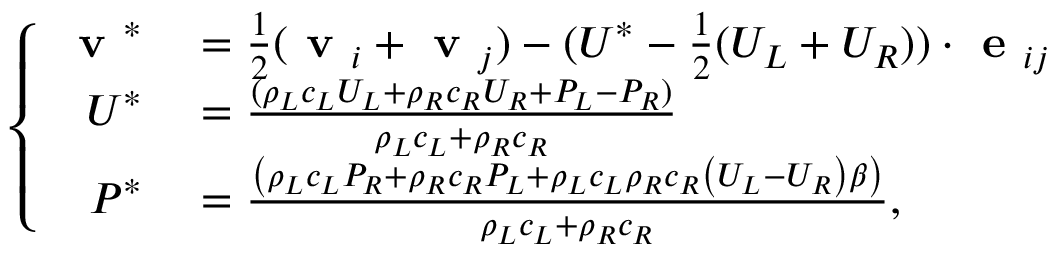<formula> <loc_0><loc_0><loc_500><loc_500>\left \{ \begin{array} { r l } { v ^ { * } } & = \frac { 1 } { 2 } ( v _ { i } + v _ { j } ) - ( U ^ { * } - \frac { 1 } { 2 } ( U _ { L } + U _ { R } ) ) \cdot e _ { i j } } \\ { U ^ { * } } & = \frac { ( \rho _ { L } c _ { L } U _ { L } + \rho _ { R } c _ { R } U _ { R } + P _ { L } - P _ { R } ) } { \rho _ { L } c _ { L } + \rho _ { R } c _ { R } } } \\ { P ^ { * } } & = \frac { \left ( \rho _ { L } c _ { L } P _ { R } + \rho _ { R } c _ { R } P _ { L } + \rho _ { L } c _ { L } \rho _ { R } c _ { R } \left ( U _ { L } - U _ { R } \right ) \beta \right ) } { \rho _ { L } c _ { L } + \rho _ { R } c _ { R } } , } \end{array}</formula> 